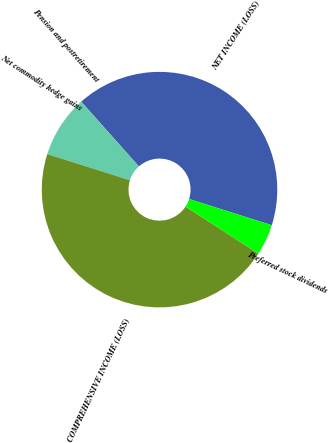Convert chart to OTSL. <chart><loc_0><loc_0><loc_500><loc_500><pie_chart><fcel>NET INCOME (LOSS)<fcel>Pension and postretirement<fcel>Net commodity hedge gains<fcel>COMPREHENSIVE INCOME (LOSS)<fcel>Preferred stock dividends<nl><fcel>41.46%<fcel>0.01%<fcel>8.54%<fcel>45.72%<fcel>4.27%<nl></chart> 